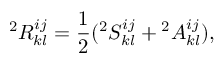<formula> <loc_0><loc_0><loc_500><loc_500>{ } ^ { 2 } R _ { k l } ^ { i j } = \frac { 1 } { 2 } ^ { 2 } S _ { k l } ^ { i j } ^ { 2 } A _ { k l } ^ { i j } ) ,</formula> 